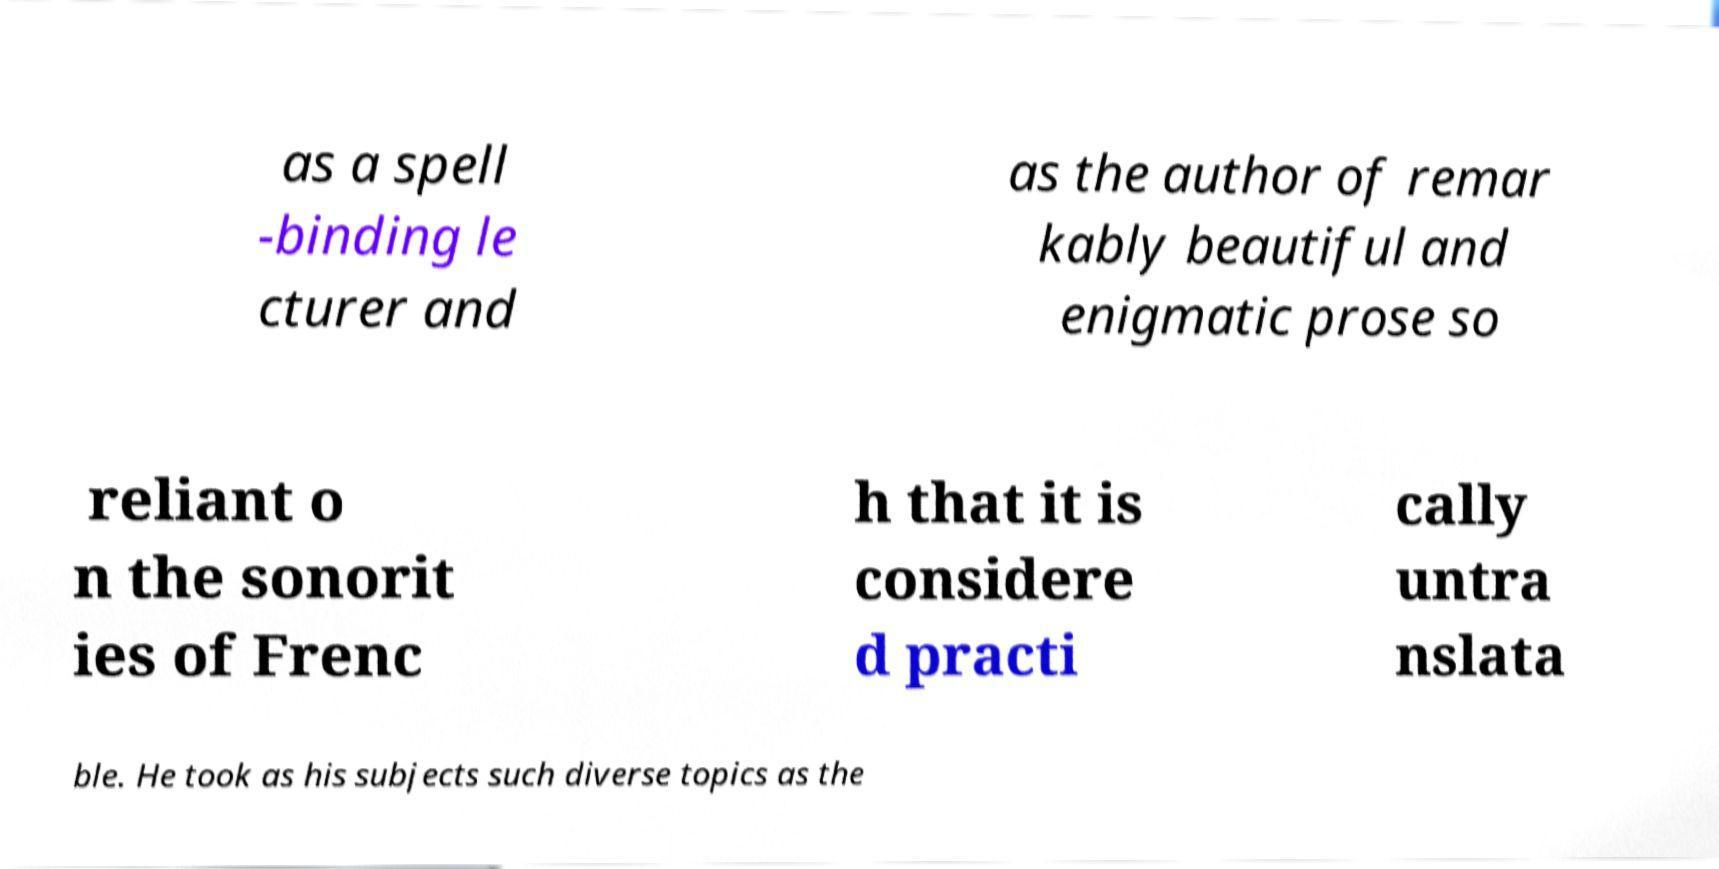Please read and relay the text visible in this image. What does it say? as a spell -binding le cturer and as the author of remar kably beautiful and enigmatic prose so reliant o n the sonorit ies of Frenc h that it is considere d practi cally untra nslata ble. He took as his subjects such diverse topics as the 